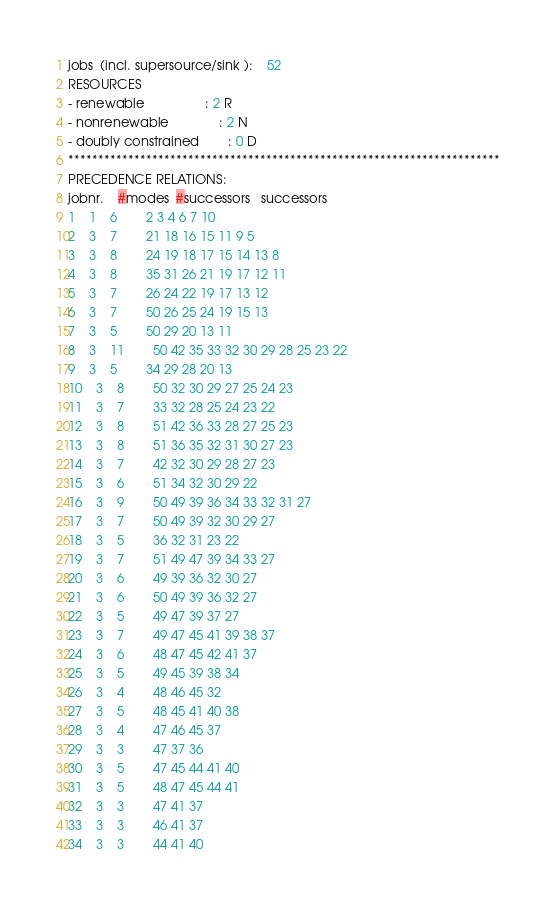<code> <loc_0><loc_0><loc_500><loc_500><_ObjectiveC_>jobs  (incl. supersource/sink ):	52
RESOURCES
- renewable                 : 2 R
- nonrenewable              : 2 N
- doubly constrained        : 0 D
************************************************************************
PRECEDENCE RELATIONS:
jobnr.    #modes  #successors   successors
1	1	6		2 3 4 6 7 10 
2	3	7		21 18 16 15 11 9 5 
3	3	8		24 19 18 17 15 14 13 8 
4	3	8		35 31 26 21 19 17 12 11 
5	3	7		26 24 22 19 17 13 12 
6	3	7		50 26 25 24 19 15 13 
7	3	5		50 29 20 13 11 
8	3	11		50 42 35 33 32 30 29 28 25 23 22 
9	3	5		34 29 28 20 13 
10	3	8		50 32 30 29 27 25 24 23 
11	3	7		33 32 28 25 24 23 22 
12	3	8		51 42 36 33 28 27 25 23 
13	3	8		51 36 35 32 31 30 27 23 
14	3	7		42 32 30 29 28 27 23 
15	3	6		51 34 32 30 29 22 
16	3	9		50 49 39 36 34 33 32 31 27 
17	3	7		50 49 39 32 30 29 27 
18	3	5		36 32 31 23 22 
19	3	7		51 49 47 39 34 33 27 
20	3	6		49 39 36 32 30 27 
21	3	6		50 49 39 36 32 27 
22	3	5		49 47 39 37 27 
23	3	7		49 47 45 41 39 38 37 
24	3	6		48 47 45 42 41 37 
25	3	5		49 45 39 38 34 
26	3	4		48 46 45 32 
27	3	5		48 45 41 40 38 
28	3	4		47 46 45 37 
29	3	3		47 37 36 
30	3	5		47 45 44 41 40 
31	3	5		48 47 45 44 41 
32	3	3		47 41 37 
33	3	3		46 41 37 
34	3	3		44 41 40 </code> 